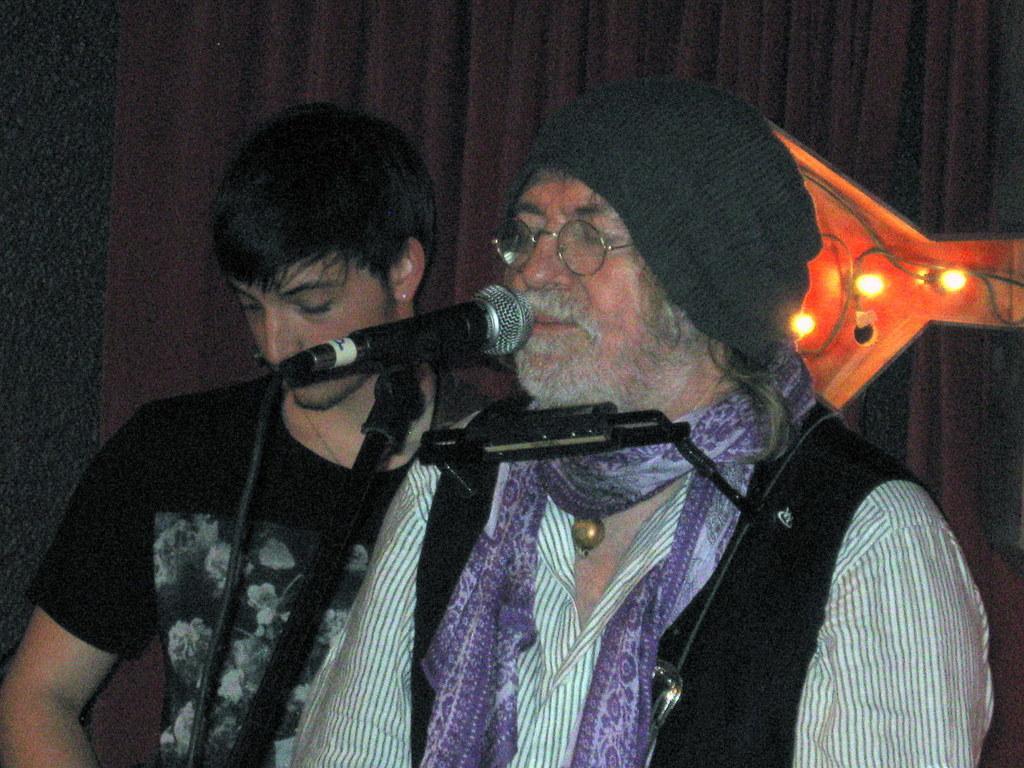Could you give a brief overview of what you see in this image? In this image on the right, there is a man, he wears a shirt, scarf, jacket, he is singing, in front of him there is a mic. On the left there is a man, he wears a t shirt. In the background there are lights, curtains. 